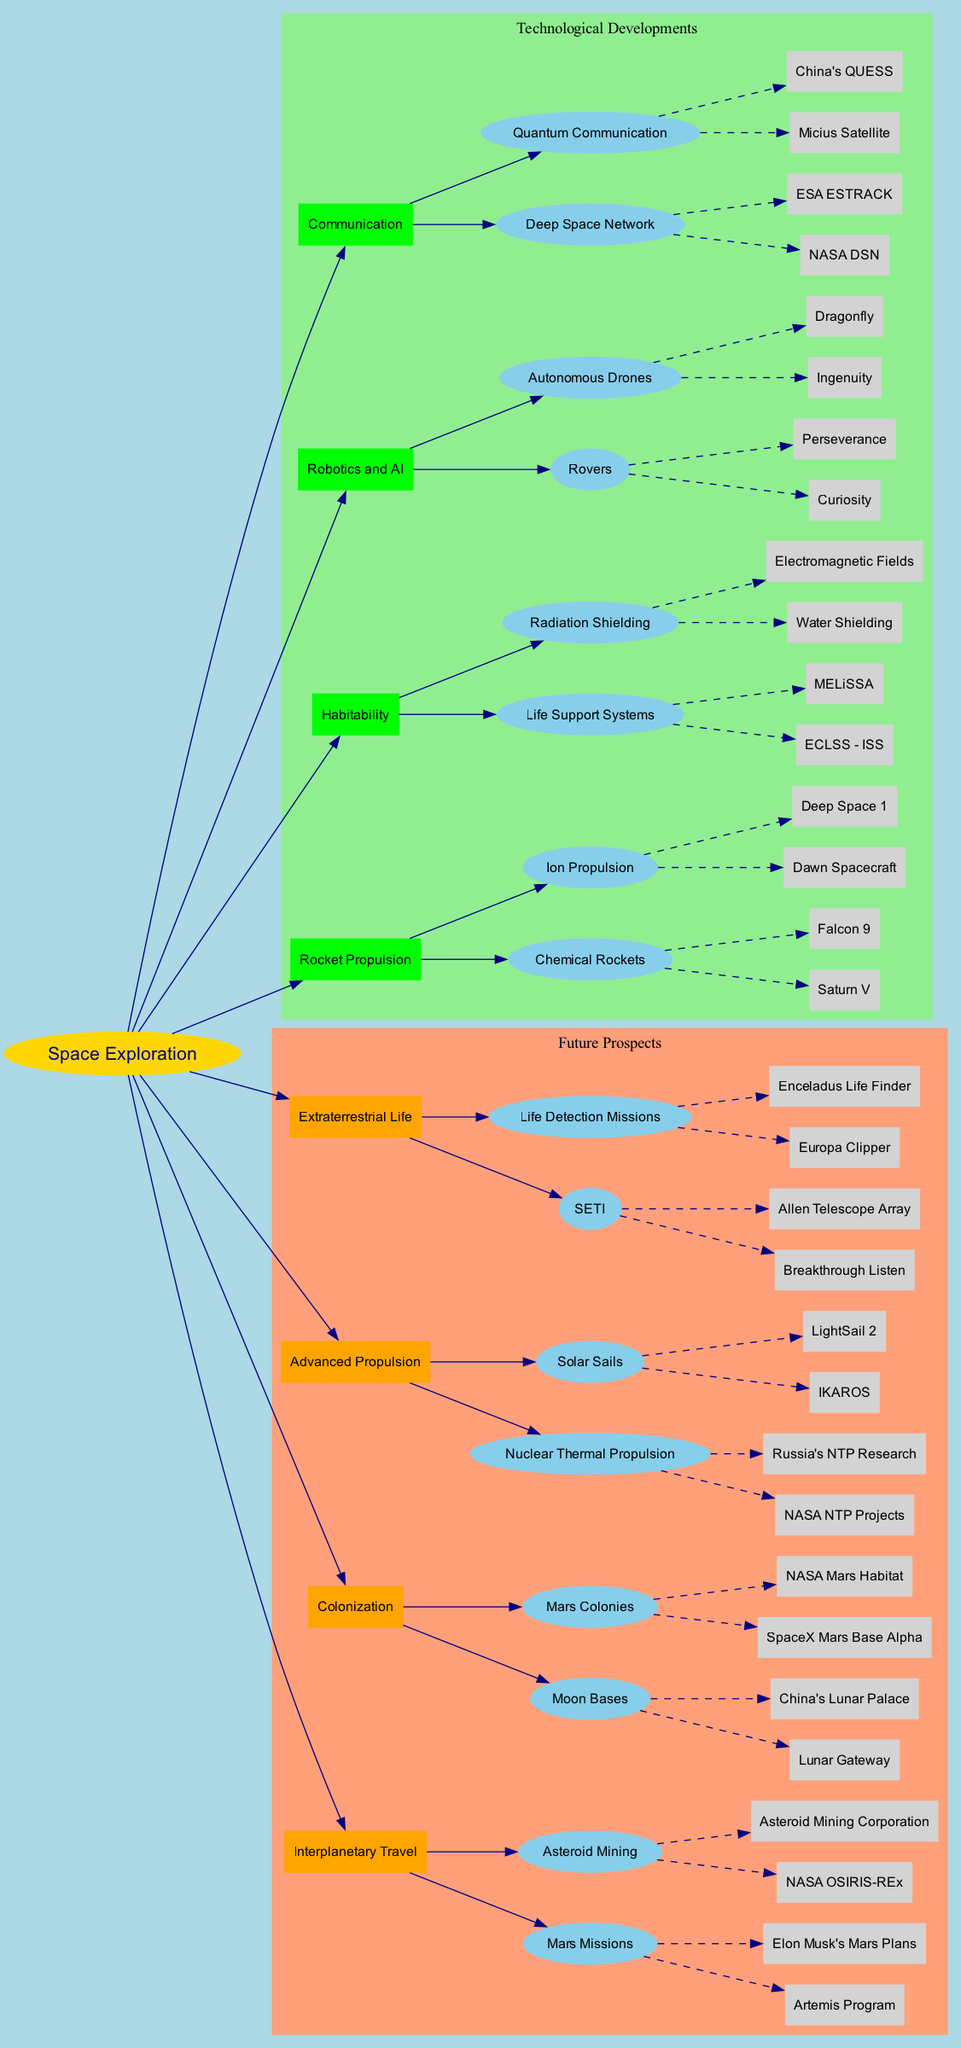What are the two types of rocket propulsion mentioned? The diagram lists two main categories of rocket propulsion: Chemical Rockets and Ion Propulsion. This information is found under the "Technological Developments" section of the diagram.
Answer: Chemical Rockets, Ion Propulsion How many Mars missions are listed in Future Prospects? In the "Future Prospects" section, there are two Mars missions specified under "Mars Missions": Artemis Program and Elon Musk's Mars Plans. Therefore, the count is directly derived from this list.
Answer: 2 What aims to develop life support systems for space habitats? The "Life Support Systems" is a specific example categorized under "Habitability" in the "Technological Developments." It shows the aim to create systems such as ECLSS - ISS and MELiSSA for sustaining life in space.
Answer: Life Support Systems Which space communication technology utilizes quantum mechanics? Within the "Communication" category under "Technological Developments," quantum communication is highlighted. The example given is China's QUESS, which illustrates the advancements in this field.
Answer: Quantum Communication How many types of advanced propulsion methods are outlined in the diagram? The "Advanced Propulsion" node details two specific methods: Nuclear Thermal Propulsion and Solar Sails, making it clear that there are two types indicated here.
Answer: 2 What is associated with Mars Colonies in Future Prospects? Within the "Colonization" subcategory of "Future Prospects," two specific examples are provided for Mars Colonies: SpaceX Mars Base Alpha and NASA Mars Habitat, indicating the focus on building colonies on Mars.
Answer: SpaceX Mars Base Alpha, NASA Mars Habitat What technology is common between the Dawn spacecraft and Deep Space 1? Both spacecraft are listed as examples of "Ion Propulsion" under the "Rocket Propulsion" section, which indicates they share this innovative propulsion technology for deep space exploration.
Answer: Ion Propulsion Which technology is utilized by Ingenuity and Dragonfly? Ingenuity and Dragonfly are both categorized under "Autonomous Drones," part of the "Robotics and AI" section of the diagram, showcasing how this technology encompasses various drone advancements.
Answer: Autonomous Drones 